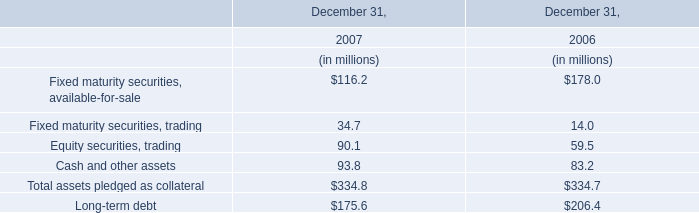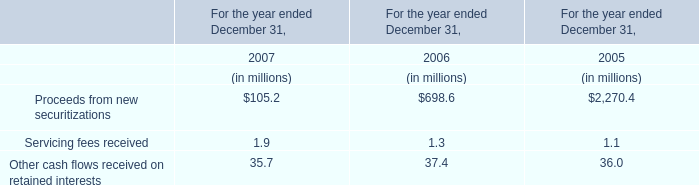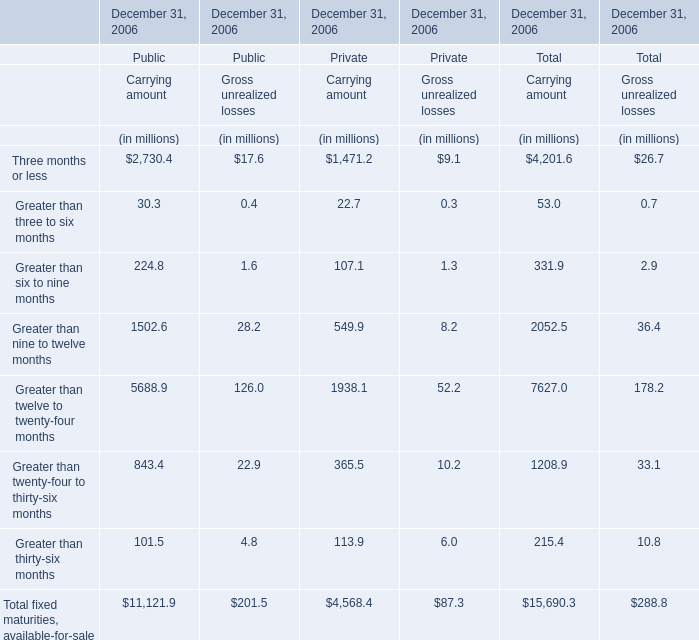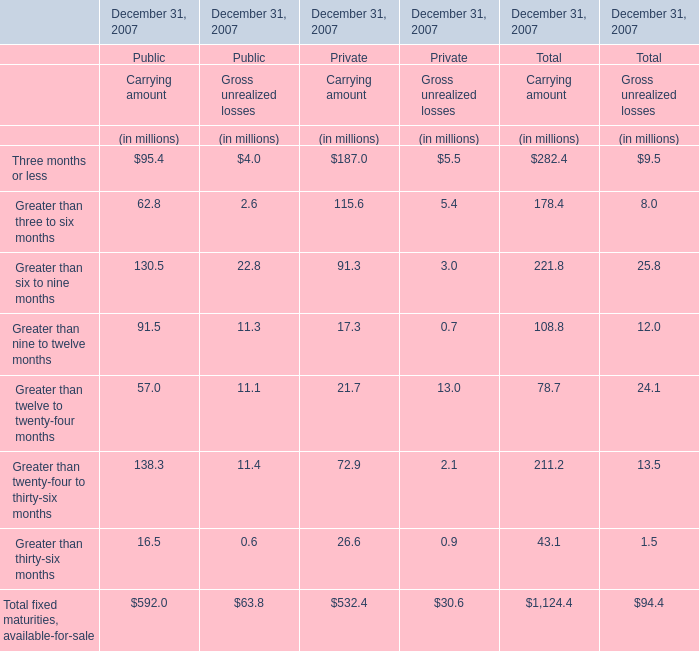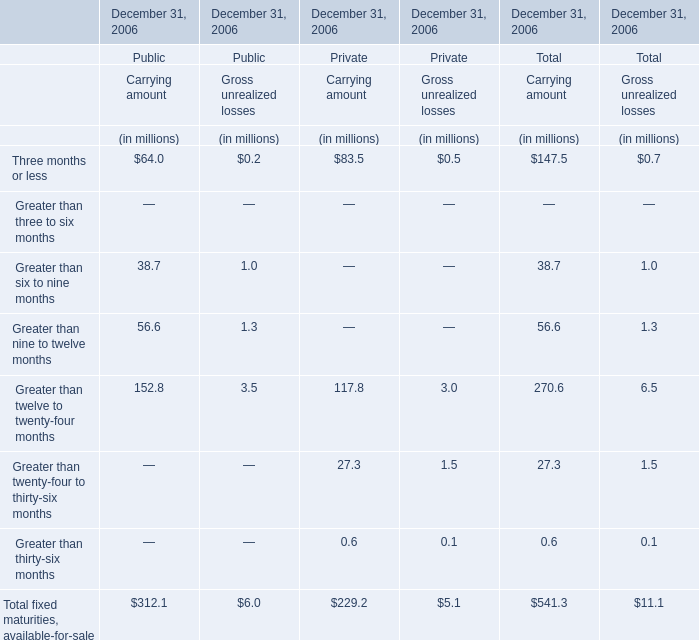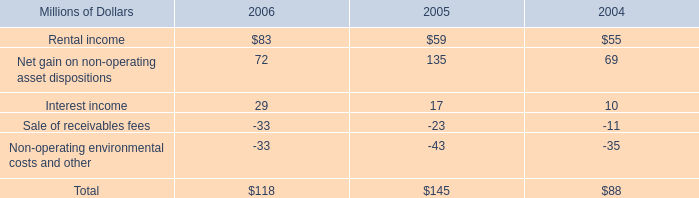what was the percentage change in rental income from 2004 to 2005? 
Computations: ((59 - 55) / 55)
Answer: 0.07273. 